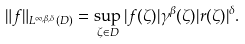Convert formula to latex. <formula><loc_0><loc_0><loc_500><loc_500>\| f \| _ { L ^ { \infty , \beta , \delta } ( D ) } = \sup _ { \zeta \in D } | f ( \zeta ) | \gamma ^ { \beta } ( \zeta ) | r ( \zeta ) | ^ { \delta } .</formula> 